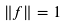<formula> <loc_0><loc_0><loc_500><loc_500>\left \| f \right \| = 1</formula> 